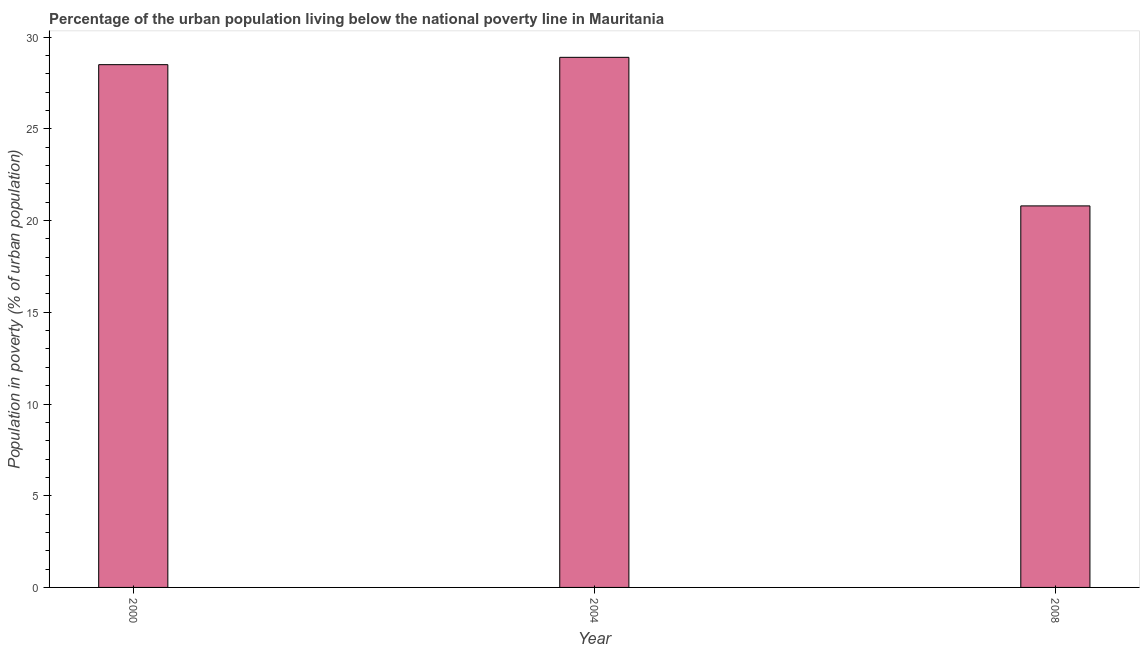Does the graph contain any zero values?
Give a very brief answer. No. What is the title of the graph?
Offer a very short reply. Percentage of the urban population living below the national poverty line in Mauritania. What is the label or title of the Y-axis?
Offer a terse response. Population in poverty (% of urban population). What is the percentage of urban population living below poverty line in 2000?
Offer a terse response. 28.5. Across all years, what is the maximum percentage of urban population living below poverty line?
Ensure brevity in your answer.  28.9. Across all years, what is the minimum percentage of urban population living below poverty line?
Provide a short and direct response. 20.8. In which year was the percentage of urban population living below poverty line maximum?
Provide a short and direct response. 2004. What is the sum of the percentage of urban population living below poverty line?
Provide a succinct answer. 78.2. What is the average percentage of urban population living below poverty line per year?
Give a very brief answer. 26.07. What is the median percentage of urban population living below poverty line?
Keep it short and to the point. 28.5. In how many years, is the percentage of urban population living below poverty line greater than 24 %?
Provide a short and direct response. 2. What is the ratio of the percentage of urban population living below poverty line in 2004 to that in 2008?
Your response must be concise. 1.39. What is the difference between the highest and the lowest percentage of urban population living below poverty line?
Provide a succinct answer. 8.1. What is the difference between two consecutive major ticks on the Y-axis?
Make the answer very short. 5. What is the Population in poverty (% of urban population) in 2004?
Your response must be concise. 28.9. What is the Population in poverty (% of urban population) of 2008?
Offer a very short reply. 20.8. What is the difference between the Population in poverty (% of urban population) in 2000 and 2008?
Make the answer very short. 7.7. What is the ratio of the Population in poverty (% of urban population) in 2000 to that in 2004?
Make the answer very short. 0.99. What is the ratio of the Population in poverty (% of urban population) in 2000 to that in 2008?
Give a very brief answer. 1.37. What is the ratio of the Population in poverty (% of urban population) in 2004 to that in 2008?
Make the answer very short. 1.39. 